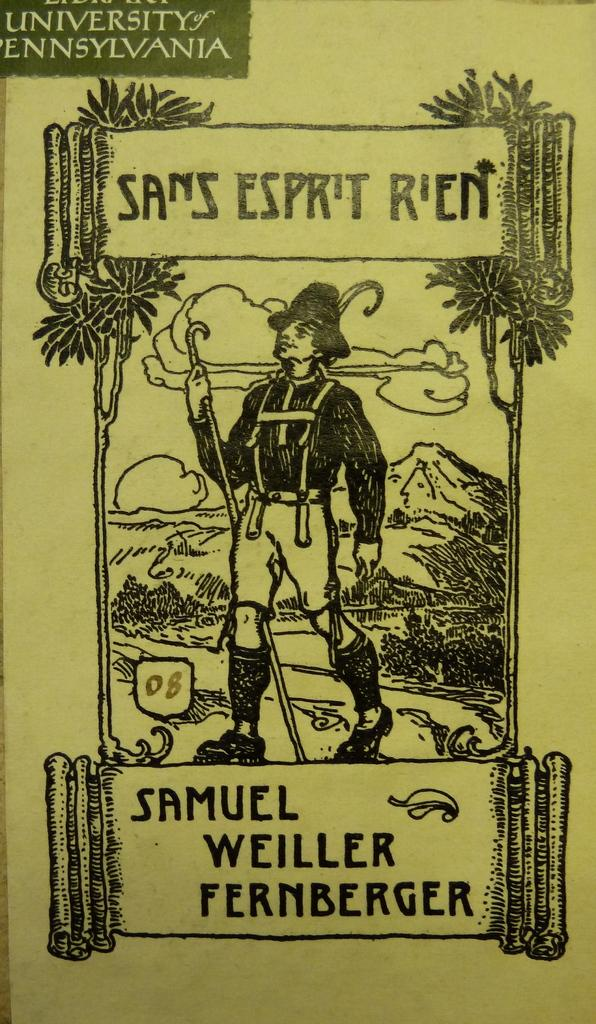<image>
Offer a succinct explanation of the picture presented. A publication from the University of Pennsylvania written by Samuel Weiller Fernberger. 